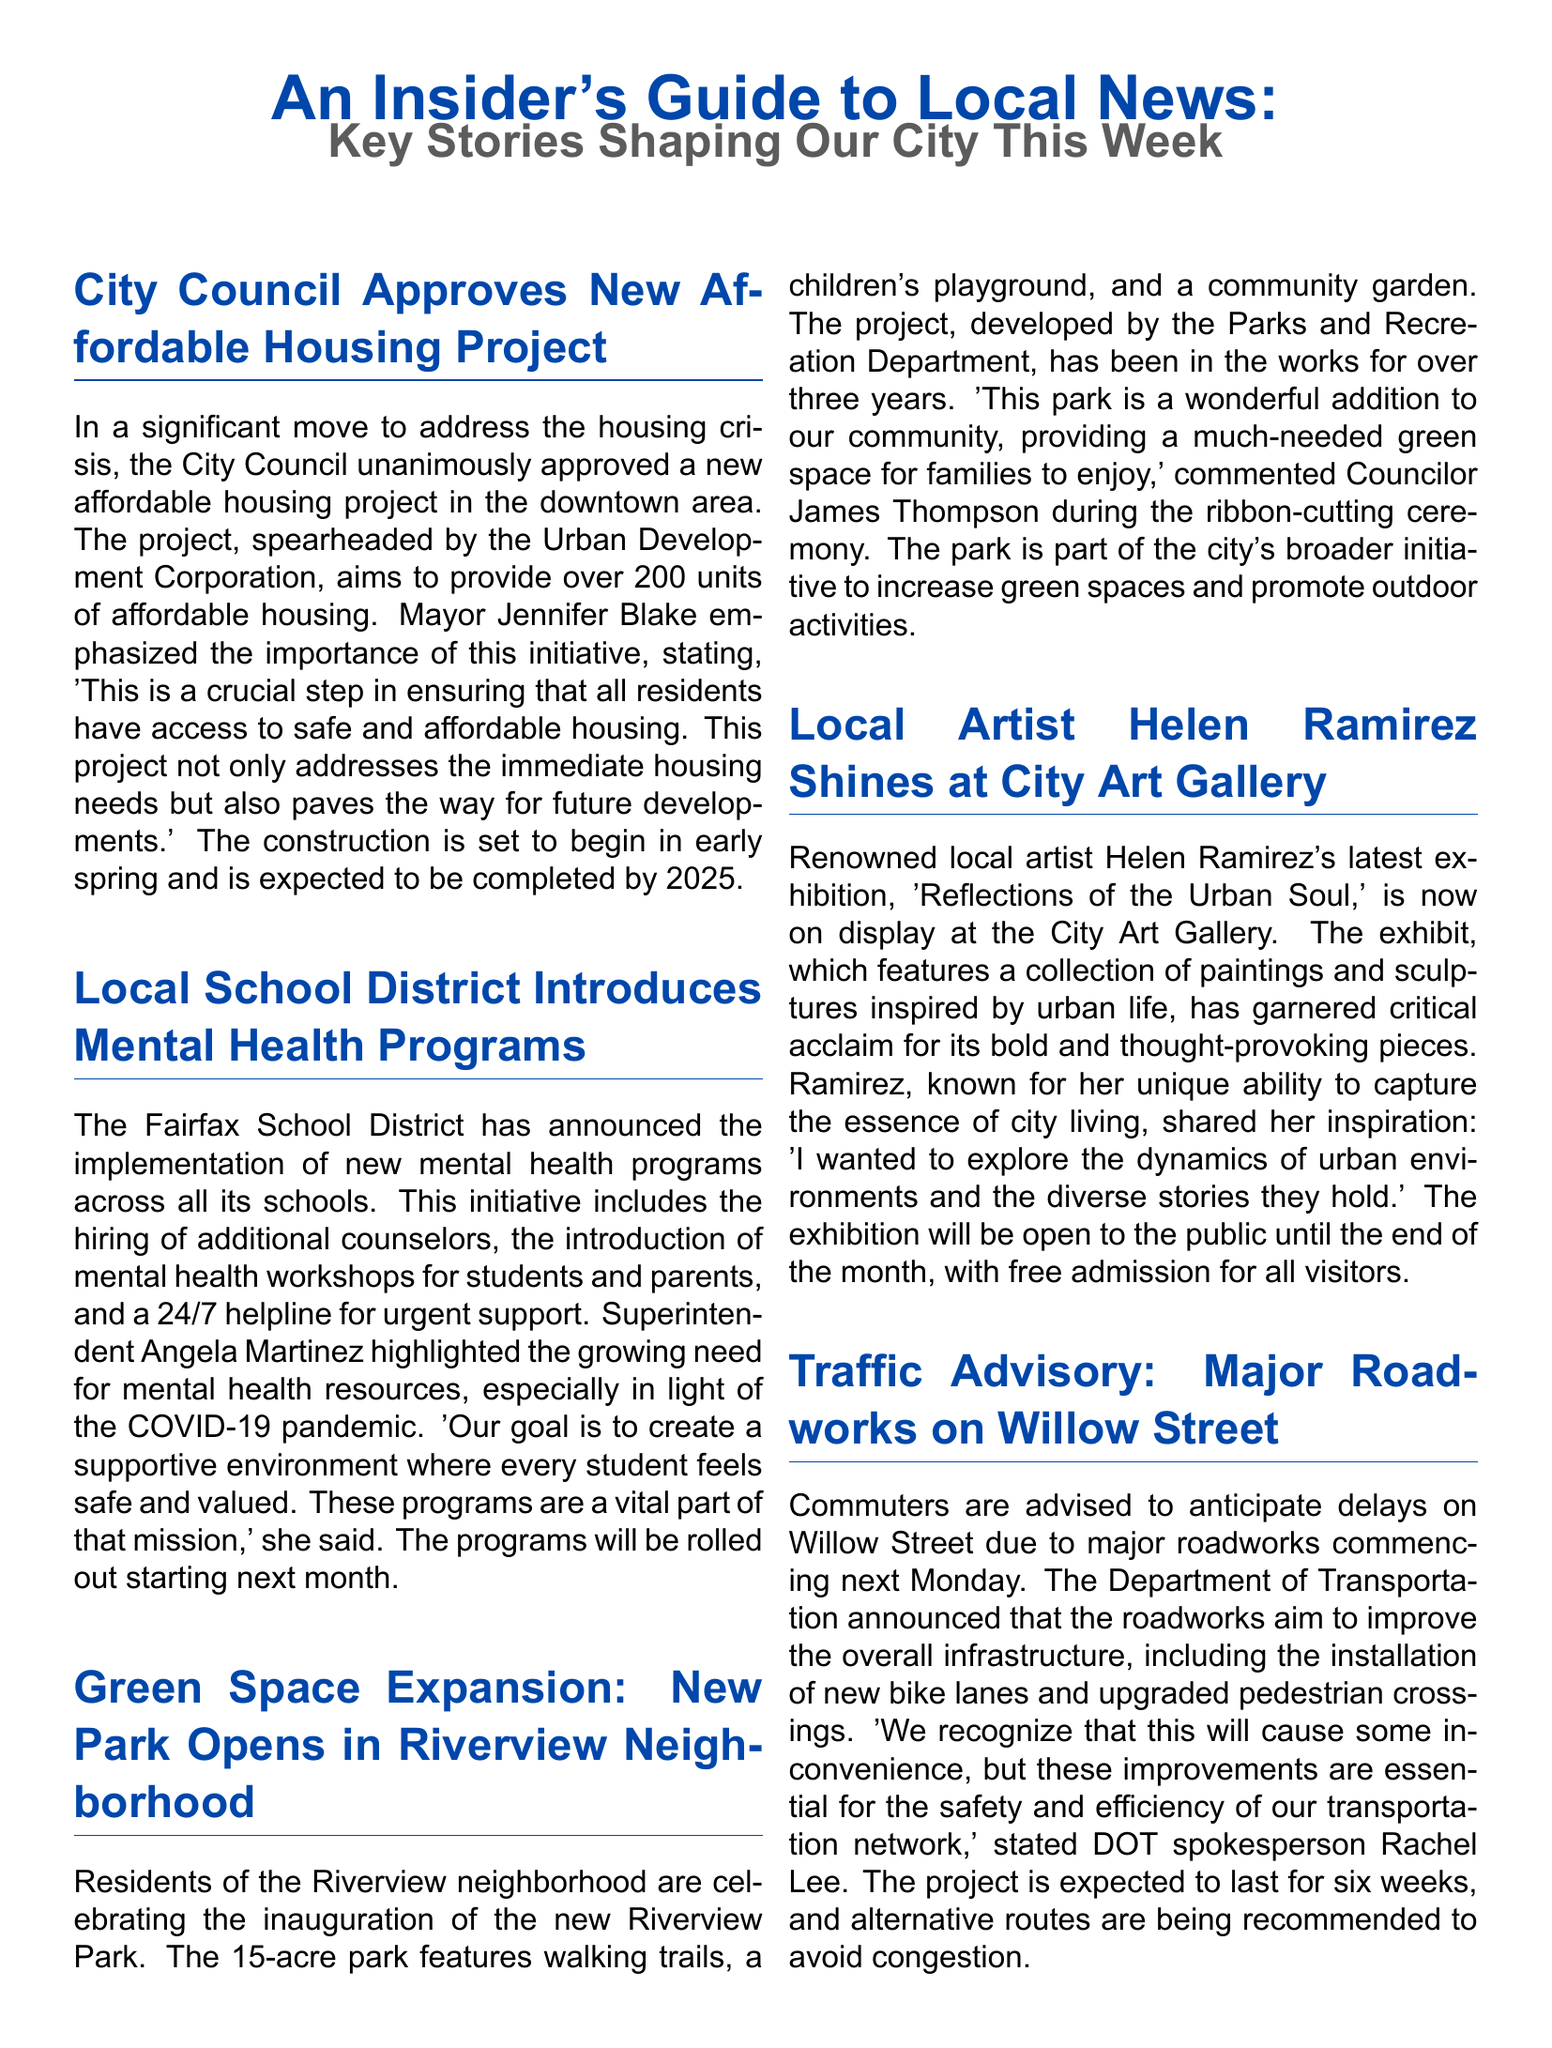what is the title of the project approved by the City Council? The title of the project is "new affordable housing project."
Answer: new affordable housing project how many units will the new affordable housing project provide? The document states that the project aims to provide over 200 units.
Answer: over 200 units who is the Superintendent of the Fairfax School District? The Superintendent of the Fairfax School District is Angela Martinez.
Answer: Angela Martinez what is the name of the local artist whose exhibition is at the City Art Gallery? The local artist is Helen Ramirez.
Answer: Helen Ramirez how long will the major roadworks on Willow Street last? The document mentions that the roadworks are expected to last for six weeks.
Answer: six weeks what type of program has the Fairfax School District introduced? The Fairfax School District has introduced mental health programs.
Answer: mental health programs how many acres is the new Riverview Park? The new Riverview Park covers 15 acres.
Answer: 15 acres what is the name of the exhibition by Helen Ramirez? The exhibition is titled "Reflections of the Urban Soul."
Answer: Reflections of the Urban Soul who emphasized the importance of the affordable housing initiative? Mayor Jennifer Blake emphasized the importance of this initiative.
Answer: Mayor Jennifer Blake 